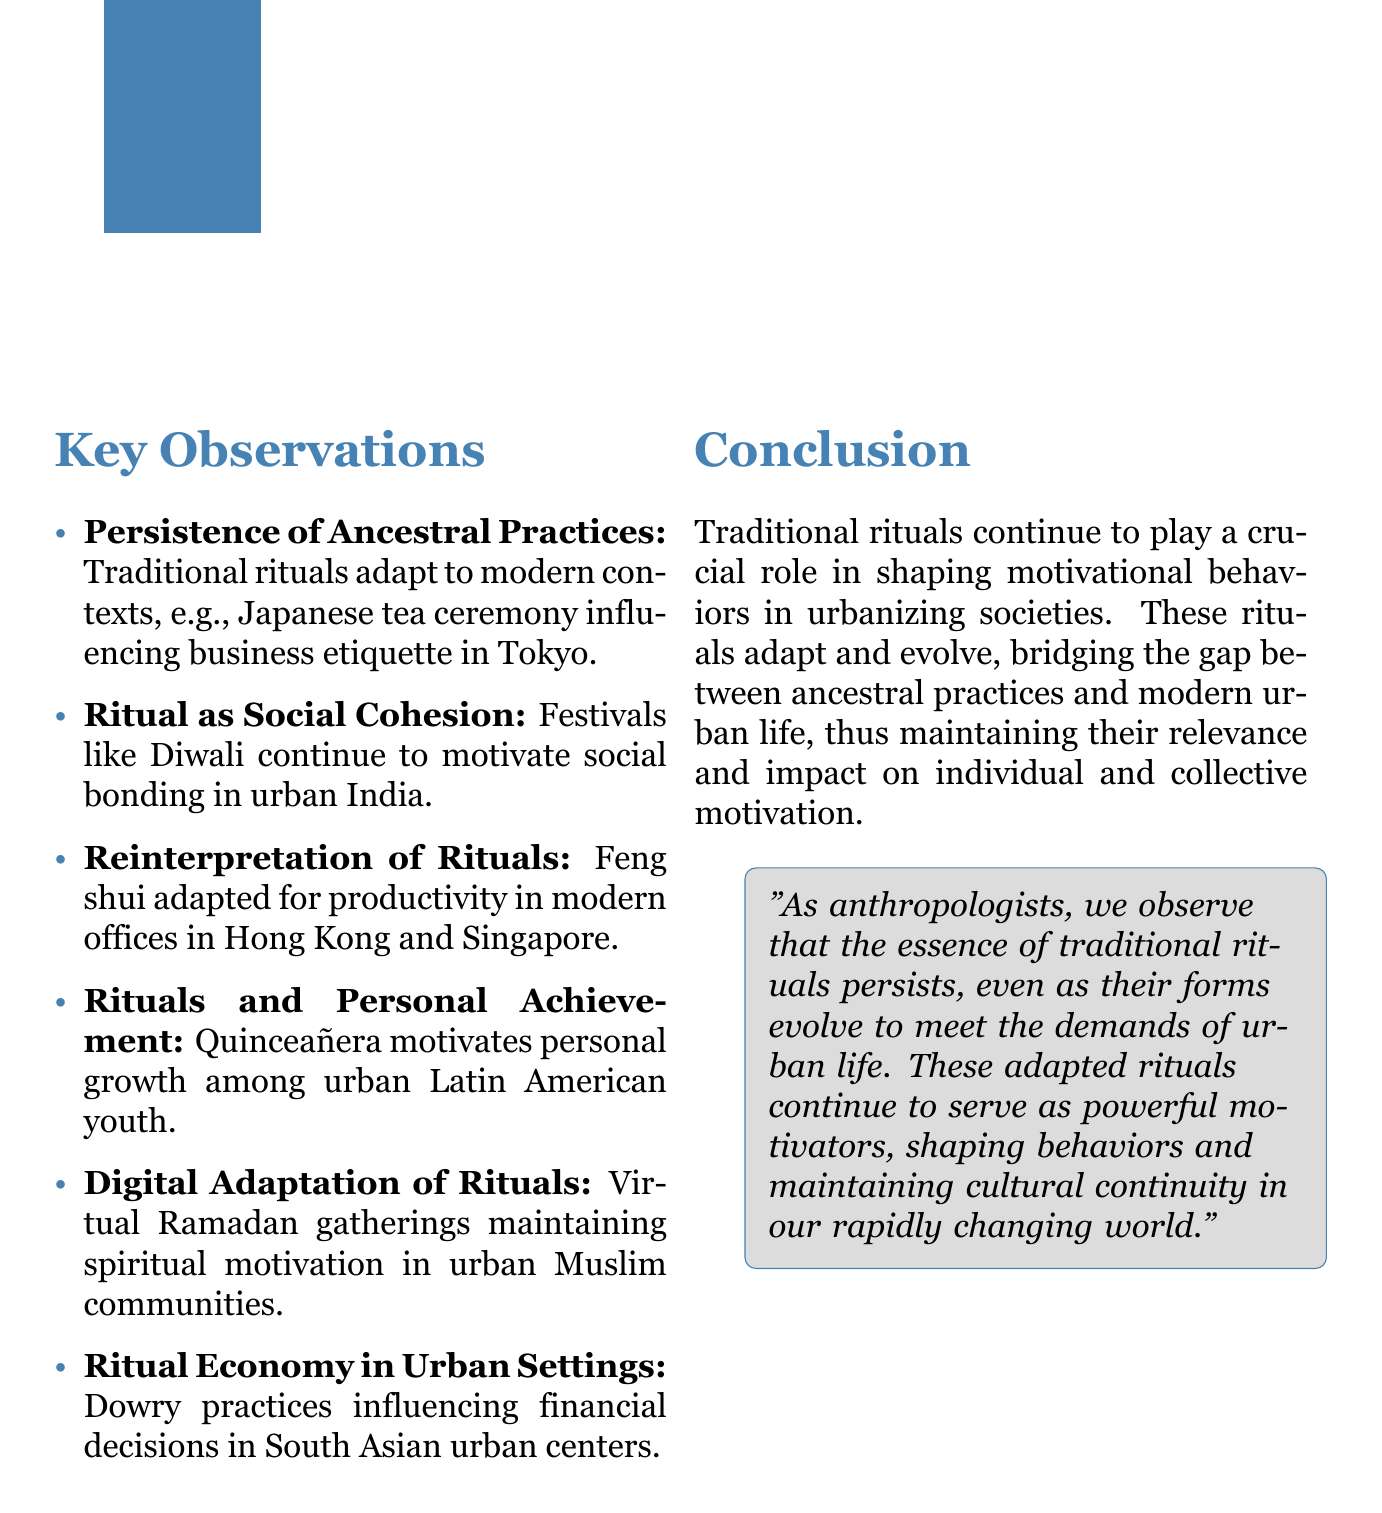What is the main topic of the document? The main topic is outlined at the beginning of the document, which focuses on the influence of traditional rituals on motivation in modern contexts.
Answer: Role of Traditional Rituals in Shaping Modern Motivational Behaviors in Urbanizing Societies What festival is mentioned as a unifying force in urban environments? The document specifically highlights a traditional festival that motivates social bonding in urban India.
Answer: Diwali Which ritual is associated with personal achievement in Latin American cultures? The notes provide an example of a coming-of-age ritual that motivates personal growth among urban youth.
Answer: Quinceañera What adaptation of traditional rituals is mentioned during the COVID-19 pandemic? The document discusses a specific cultural practice that transitioned to an online format to maintain social connections during the pandemic.
Answer: Virtual Ramadan gatherings How do traditional rituals affect economic behaviors in urban settings? The document provides insight into how specific economic practices continue to influence financial decision-making in urban areas.
Answer: Dowry practices What does the conclusion emphasize regarding traditional rituals? The conclusion summarizes the overall significance of these practices in adapting to modern urban life while maintaining relevance.
Answer: Crucial role in shaping motivational behaviors 